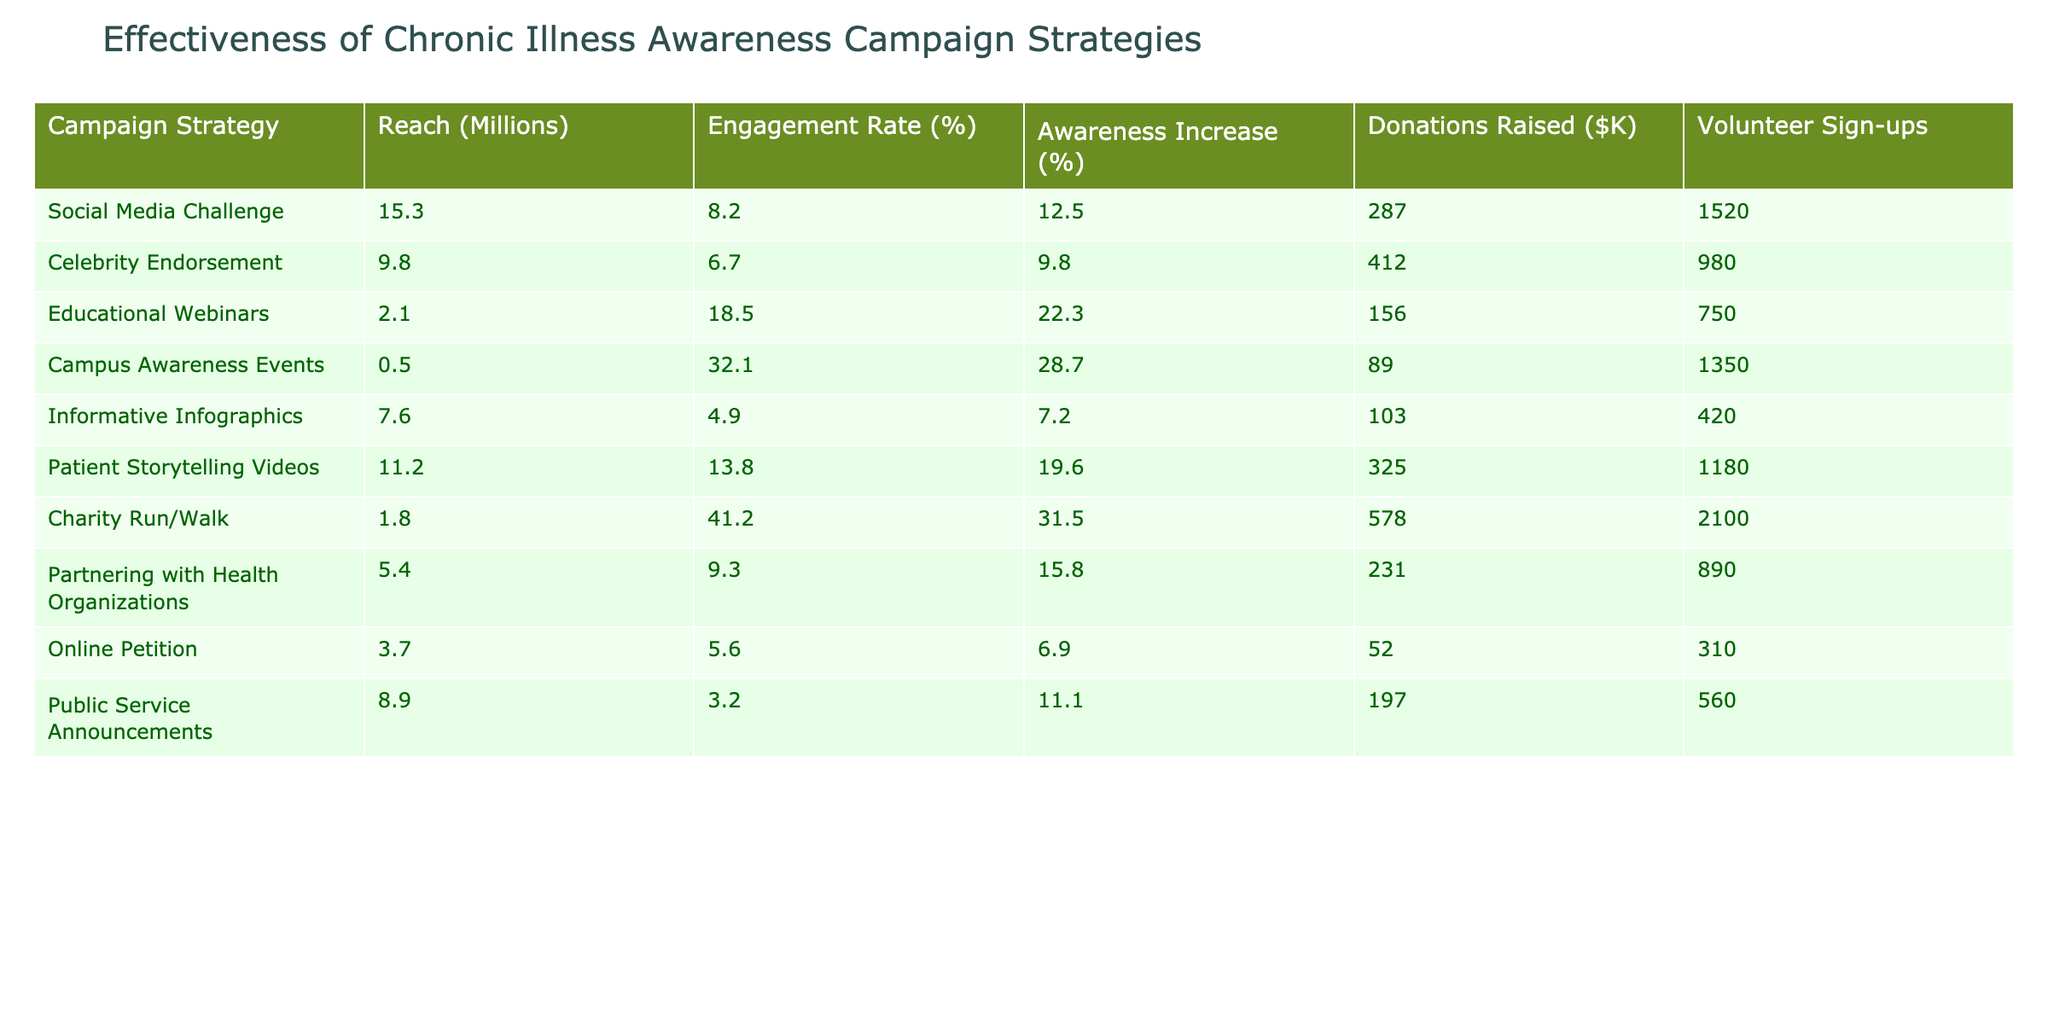What is the reach in millions of the Educational Webinars strategy? The reach value for Educational Webinars is specifically listed in the table, and it states 2.1 million.
Answer: 2.1 Which campaign strategy had the highest engagement rate? By comparing the engagement rates from the table, Campus Awareness Events has the highest engagement rate at 32.1%.
Answer: 32.1% How much money was raised through the Charity Run/Walk strategy? The table clearly shows that the donations raised for the Charity Run/Walk strategy were $578K.
Answer: 578 What is the awareness increase percentage for Patient Storytelling Videos? The awareness increase for Patient Storytelling Videos is displayed in the table, showing a percentage increase of 19.6%.
Answer: 19.6 Which campaign strategy led to the lowest volunteer sign-ups? Looking at the volunteer sign-ups in the table, Online Petition had the lowest value at 310 sign-ups.
Answer: 310 What is the average reach of all the campaign strategies listed? To find the average reach, add all the reach values (15.3 + 9.8 + 2.1 + 0.5 + 7.6 + 11.2 + 1.8 + 5.4 + 3.7 + 8.9) which equals 65.3 million. Then, divide by 10 (the number of strategies) to get 6.53 million.
Answer: 6.53 Does the Celebrity Endorsement strategy have a higher awareness increase than Informative Infographics? Comparing the awareness increase percentages, Celebrity Endorsement has 9.8% while Informative Infographics has 7.2%. Since 9.8% is greater than 7.2%, the answer is yes.
Answer: Yes Which campaign strategy raised the most donations and what was the amount? Looking through the table, Charity Run/Walk raised the most donations at $578K.
Answer: $578K If we sum the volunteer sign-ups for both Social Media Challenge and Campus Awareness Events, what is the total? Social Media Challenge has 1520 volunteer sign-ups and Campus Awareness Events has 1350. Adding these gives 1520 + 1350 = 2870 volunteer sign-ups in total.
Answer: 2870 Is the engagement rate for the Online Petition higher than that of the Informative Infographics? The engagement rate for Online Petition is 5.6% and Informative Infographics is 4.9%. Since 5.6% is greater than 4.9%, the answer is yes.
Answer: Yes 